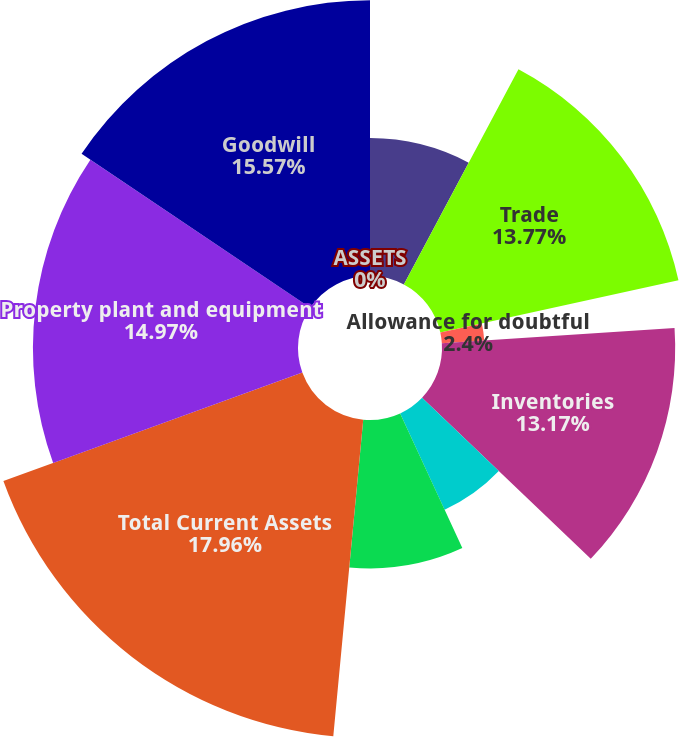<chart> <loc_0><loc_0><loc_500><loc_500><pie_chart><fcel>ASSETS<fcel>Cash and cash equivalents<fcel>Trade<fcel>Allowance for doubtful<fcel>Inventories<fcel>Deferred income taxes<fcel>Prepaid expenses and other<fcel>Total Current Assets<fcel>Property plant and equipment<fcel>Goodwill<nl><fcel>0.0%<fcel>7.79%<fcel>13.77%<fcel>2.4%<fcel>13.17%<fcel>5.99%<fcel>8.38%<fcel>17.96%<fcel>14.97%<fcel>15.57%<nl></chart> 